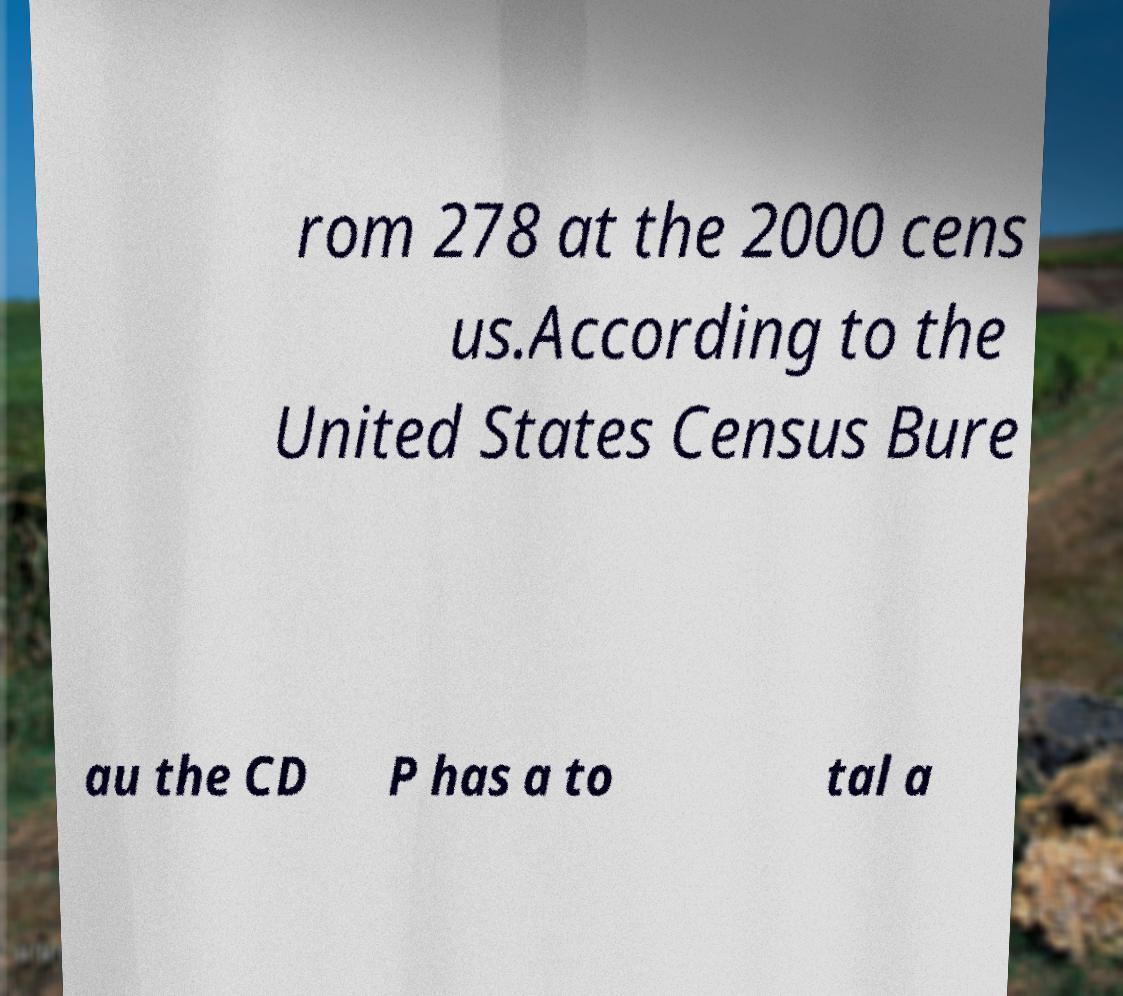I need the written content from this picture converted into text. Can you do that? rom 278 at the 2000 cens us.According to the United States Census Bure au the CD P has a to tal a 